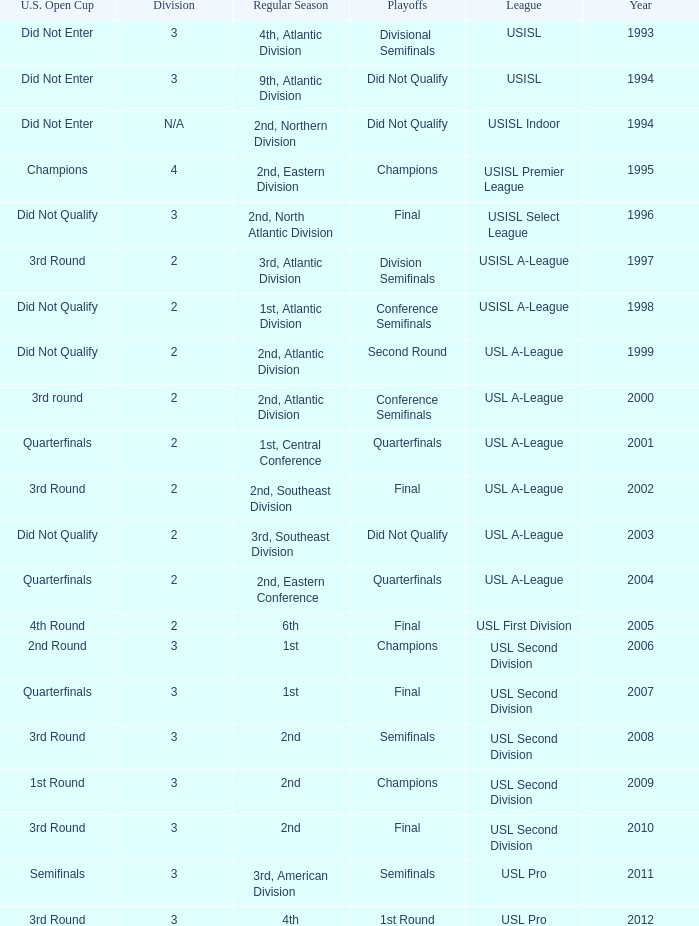How many division  did not qualify for u.s. open cup in 2003 2.0. 